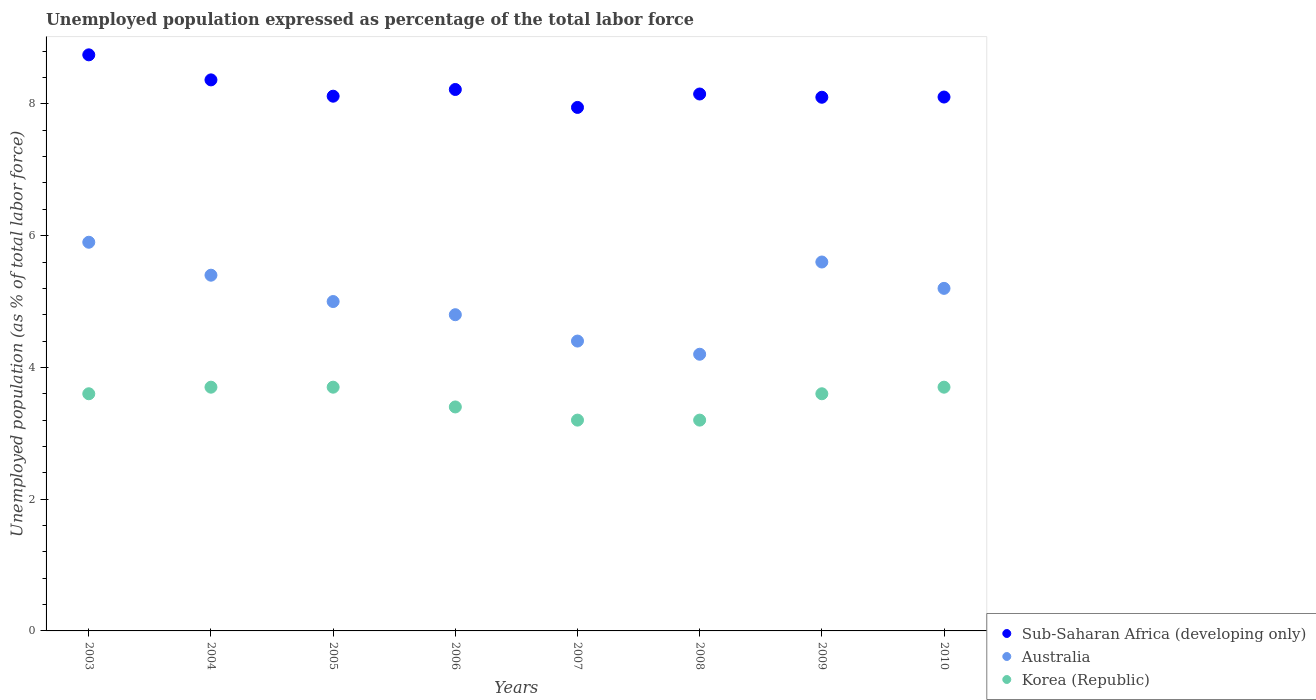How many different coloured dotlines are there?
Offer a very short reply. 3. What is the unemployment in in Korea (Republic) in 2004?
Keep it short and to the point. 3.7. Across all years, what is the maximum unemployment in in Sub-Saharan Africa (developing only)?
Offer a very short reply. 8.74. Across all years, what is the minimum unemployment in in Australia?
Offer a very short reply. 4.2. In which year was the unemployment in in Korea (Republic) maximum?
Provide a short and direct response. 2004. In which year was the unemployment in in Australia minimum?
Keep it short and to the point. 2008. What is the total unemployment in in Australia in the graph?
Offer a terse response. 40.5. What is the difference between the unemployment in in Korea (Republic) in 2006 and that in 2008?
Provide a short and direct response. 0.2. What is the difference between the unemployment in in Sub-Saharan Africa (developing only) in 2004 and the unemployment in in Korea (Republic) in 2009?
Ensure brevity in your answer.  4.76. What is the average unemployment in in Korea (Republic) per year?
Your answer should be compact. 3.51. In the year 2010, what is the difference between the unemployment in in Sub-Saharan Africa (developing only) and unemployment in in Australia?
Provide a short and direct response. 2.9. What is the ratio of the unemployment in in Sub-Saharan Africa (developing only) in 2005 to that in 2006?
Your answer should be very brief. 0.99. Is the unemployment in in Sub-Saharan Africa (developing only) in 2006 less than that in 2008?
Offer a very short reply. No. What is the difference between the highest and the second highest unemployment in in Korea (Republic)?
Your answer should be very brief. 0. What is the difference between the highest and the lowest unemployment in in Australia?
Your answer should be very brief. 1.7. Is the unemployment in in Australia strictly less than the unemployment in in Sub-Saharan Africa (developing only) over the years?
Your answer should be very brief. Yes. How many dotlines are there?
Provide a short and direct response. 3. What is the difference between two consecutive major ticks on the Y-axis?
Offer a terse response. 2. How many legend labels are there?
Keep it short and to the point. 3. What is the title of the graph?
Your response must be concise. Unemployed population expressed as percentage of the total labor force. What is the label or title of the X-axis?
Your answer should be very brief. Years. What is the label or title of the Y-axis?
Make the answer very short. Unemployed population (as % of total labor force). What is the Unemployed population (as % of total labor force) in Sub-Saharan Africa (developing only) in 2003?
Provide a succinct answer. 8.74. What is the Unemployed population (as % of total labor force) of Australia in 2003?
Your response must be concise. 5.9. What is the Unemployed population (as % of total labor force) in Korea (Republic) in 2003?
Give a very brief answer. 3.6. What is the Unemployed population (as % of total labor force) of Sub-Saharan Africa (developing only) in 2004?
Provide a short and direct response. 8.36. What is the Unemployed population (as % of total labor force) in Australia in 2004?
Provide a short and direct response. 5.4. What is the Unemployed population (as % of total labor force) of Korea (Republic) in 2004?
Give a very brief answer. 3.7. What is the Unemployed population (as % of total labor force) in Sub-Saharan Africa (developing only) in 2005?
Provide a short and direct response. 8.12. What is the Unemployed population (as % of total labor force) in Korea (Republic) in 2005?
Provide a succinct answer. 3.7. What is the Unemployed population (as % of total labor force) in Sub-Saharan Africa (developing only) in 2006?
Your response must be concise. 8.22. What is the Unemployed population (as % of total labor force) of Australia in 2006?
Keep it short and to the point. 4.8. What is the Unemployed population (as % of total labor force) in Korea (Republic) in 2006?
Keep it short and to the point. 3.4. What is the Unemployed population (as % of total labor force) of Sub-Saharan Africa (developing only) in 2007?
Offer a terse response. 7.95. What is the Unemployed population (as % of total labor force) in Australia in 2007?
Your answer should be very brief. 4.4. What is the Unemployed population (as % of total labor force) in Korea (Republic) in 2007?
Provide a succinct answer. 3.2. What is the Unemployed population (as % of total labor force) in Sub-Saharan Africa (developing only) in 2008?
Provide a short and direct response. 8.15. What is the Unemployed population (as % of total labor force) in Australia in 2008?
Make the answer very short. 4.2. What is the Unemployed population (as % of total labor force) in Korea (Republic) in 2008?
Give a very brief answer. 3.2. What is the Unemployed population (as % of total labor force) of Sub-Saharan Africa (developing only) in 2009?
Provide a succinct answer. 8.1. What is the Unemployed population (as % of total labor force) in Australia in 2009?
Provide a succinct answer. 5.6. What is the Unemployed population (as % of total labor force) in Korea (Republic) in 2009?
Give a very brief answer. 3.6. What is the Unemployed population (as % of total labor force) of Sub-Saharan Africa (developing only) in 2010?
Make the answer very short. 8.1. What is the Unemployed population (as % of total labor force) of Australia in 2010?
Your answer should be compact. 5.2. What is the Unemployed population (as % of total labor force) of Korea (Republic) in 2010?
Provide a short and direct response. 3.7. Across all years, what is the maximum Unemployed population (as % of total labor force) in Sub-Saharan Africa (developing only)?
Your response must be concise. 8.74. Across all years, what is the maximum Unemployed population (as % of total labor force) of Australia?
Give a very brief answer. 5.9. Across all years, what is the maximum Unemployed population (as % of total labor force) in Korea (Republic)?
Offer a terse response. 3.7. Across all years, what is the minimum Unemployed population (as % of total labor force) in Sub-Saharan Africa (developing only)?
Offer a very short reply. 7.95. Across all years, what is the minimum Unemployed population (as % of total labor force) in Australia?
Ensure brevity in your answer.  4.2. Across all years, what is the minimum Unemployed population (as % of total labor force) of Korea (Republic)?
Keep it short and to the point. 3.2. What is the total Unemployed population (as % of total labor force) in Sub-Saharan Africa (developing only) in the graph?
Offer a terse response. 65.75. What is the total Unemployed population (as % of total labor force) of Australia in the graph?
Provide a short and direct response. 40.5. What is the total Unemployed population (as % of total labor force) in Korea (Republic) in the graph?
Ensure brevity in your answer.  28.1. What is the difference between the Unemployed population (as % of total labor force) in Sub-Saharan Africa (developing only) in 2003 and that in 2004?
Provide a short and direct response. 0.38. What is the difference between the Unemployed population (as % of total labor force) of Australia in 2003 and that in 2004?
Your answer should be compact. 0.5. What is the difference between the Unemployed population (as % of total labor force) in Korea (Republic) in 2003 and that in 2004?
Offer a very short reply. -0.1. What is the difference between the Unemployed population (as % of total labor force) of Sub-Saharan Africa (developing only) in 2003 and that in 2005?
Your answer should be compact. 0.63. What is the difference between the Unemployed population (as % of total labor force) in Korea (Republic) in 2003 and that in 2005?
Give a very brief answer. -0.1. What is the difference between the Unemployed population (as % of total labor force) in Sub-Saharan Africa (developing only) in 2003 and that in 2006?
Offer a terse response. 0.53. What is the difference between the Unemployed population (as % of total labor force) in Sub-Saharan Africa (developing only) in 2003 and that in 2007?
Make the answer very short. 0.8. What is the difference between the Unemployed population (as % of total labor force) of Sub-Saharan Africa (developing only) in 2003 and that in 2008?
Ensure brevity in your answer.  0.59. What is the difference between the Unemployed population (as % of total labor force) in Sub-Saharan Africa (developing only) in 2003 and that in 2009?
Offer a very short reply. 0.64. What is the difference between the Unemployed population (as % of total labor force) in Sub-Saharan Africa (developing only) in 2003 and that in 2010?
Your answer should be compact. 0.64. What is the difference between the Unemployed population (as % of total labor force) of Australia in 2003 and that in 2010?
Offer a terse response. 0.7. What is the difference between the Unemployed population (as % of total labor force) in Korea (Republic) in 2003 and that in 2010?
Keep it short and to the point. -0.1. What is the difference between the Unemployed population (as % of total labor force) of Sub-Saharan Africa (developing only) in 2004 and that in 2005?
Your answer should be very brief. 0.25. What is the difference between the Unemployed population (as % of total labor force) in Korea (Republic) in 2004 and that in 2005?
Provide a short and direct response. 0. What is the difference between the Unemployed population (as % of total labor force) in Sub-Saharan Africa (developing only) in 2004 and that in 2006?
Ensure brevity in your answer.  0.15. What is the difference between the Unemployed population (as % of total labor force) of Korea (Republic) in 2004 and that in 2006?
Keep it short and to the point. 0.3. What is the difference between the Unemployed population (as % of total labor force) of Sub-Saharan Africa (developing only) in 2004 and that in 2007?
Your answer should be compact. 0.42. What is the difference between the Unemployed population (as % of total labor force) of Australia in 2004 and that in 2007?
Your answer should be compact. 1. What is the difference between the Unemployed population (as % of total labor force) in Sub-Saharan Africa (developing only) in 2004 and that in 2008?
Provide a short and direct response. 0.21. What is the difference between the Unemployed population (as % of total labor force) in Sub-Saharan Africa (developing only) in 2004 and that in 2009?
Provide a short and direct response. 0.26. What is the difference between the Unemployed population (as % of total labor force) of Australia in 2004 and that in 2009?
Ensure brevity in your answer.  -0.2. What is the difference between the Unemployed population (as % of total labor force) of Korea (Republic) in 2004 and that in 2009?
Give a very brief answer. 0.1. What is the difference between the Unemployed population (as % of total labor force) in Sub-Saharan Africa (developing only) in 2004 and that in 2010?
Offer a very short reply. 0.26. What is the difference between the Unemployed population (as % of total labor force) in Sub-Saharan Africa (developing only) in 2005 and that in 2006?
Make the answer very short. -0.1. What is the difference between the Unemployed population (as % of total labor force) of Australia in 2005 and that in 2006?
Your answer should be very brief. 0.2. What is the difference between the Unemployed population (as % of total labor force) in Korea (Republic) in 2005 and that in 2006?
Offer a very short reply. 0.3. What is the difference between the Unemployed population (as % of total labor force) of Sub-Saharan Africa (developing only) in 2005 and that in 2007?
Provide a short and direct response. 0.17. What is the difference between the Unemployed population (as % of total labor force) of Australia in 2005 and that in 2007?
Provide a succinct answer. 0.6. What is the difference between the Unemployed population (as % of total labor force) of Sub-Saharan Africa (developing only) in 2005 and that in 2008?
Ensure brevity in your answer.  -0.03. What is the difference between the Unemployed population (as % of total labor force) of Australia in 2005 and that in 2008?
Provide a succinct answer. 0.8. What is the difference between the Unemployed population (as % of total labor force) of Korea (Republic) in 2005 and that in 2008?
Offer a very short reply. 0.5. What is the difference between the Unemployed population (as % of total labor force) of Sub-Saharan Africa (developing only) in 2005 and that in 2009?
Make the answer very short. 0.02. What is the difference between the Unemployed population (as % of total labor force) in Australia in 2005 and that in 2009?
Make the answer very short. -0.6. What is the difference between the Unemployed population (as % of total labor force) in Sub-Saharan Africa (developing only) in 2005 and that in 2010?
Your answer should be compact. 0.01. What is the difference between the Unemployed population (as % of total labor force) in Australia in 2005 and that in 2010?
Keep it short and to the point. -0.2. What is the difference between the Unemployed population (as % of total labor force) of Sub-Saharan Africa (developing only) in 2006 and that in 2007?
Ensure brevity in your answer.  0.27. What is the difference between the Unemployed population (as % of total labor force) of Australia in 2006 and that in 2007?
Give a very brief answer. 0.4. What is the difference between the Unemployed population (as % of total labor force) of Korea (Republic) in 2006 and that in 2007?
Your answer should be very brief. 0.2. What is the difference between the Unemployed population (as % of total labor force) in Sub-Saharan Africa (developing only) in 2006 and that in 2008?
Ensure brevity in your answer.  0.07. What is the difference between the Unemployed population (as % of total labor force) of Australia in 2006 and that in 2008?
Keep it short and to the point. 0.6. What is the difference between the Unemployed population (as % of total labor force) of Korea (Republic) in 2006 and that in 2008?
Ensure brevity in your answer.  0.2. What is the difference between the Unemployed population (as % of total labor force) in Sub-Saharan Africa (developing only) in 2006 and that in 2009?
Give a very brief answer. 0.12. What is the difference between the Unemployed population (as % of total labor force) in Australia in 2006 and that in 2009?
Your answer should be very brief. -0.8. What is the difference between the Unemployed population (as % of total labor force) in Korea (Republic) in 2006 and that in 2009?
Offer a terse response. -0.2. What is the difference between the Unemployed population (as % of total labor force) in Sub-Saharan Africa (developing only) in 2006 and that in 2010?
Your response must be concise. 0.11. What is the difference between the Unemployed population (as % of total labor force) in Sub-Saharan Africa (developing only) in 2007 and that in 2008?
Keep it short and to the point. -0.2. What is the difference between the Unemployed population (as % of total labor force) of Korea (Republic) in 2007 and that in 2008?
Provide a succinct answer. 0. What is the difference between the Unemployed population (as % of total labor force) of Sub-Saharan Africa (developing only) in 2007 and that in 2009?
Offer a terse response. -0.15. What is the difference between the Unemployed population (as % of total labor force) in Australia in 2007 and that in 2009?
Your answer should be compact. -1.2. What is the difference between the Unemployed population (as % of total labor force) in Korea (Republic) in 2007 and that in 2009?
Provide a succinct answer. -0.4. What is the difference between the Unemployed population (as % of total labor force) in Sub-Saharan Africa (developing only) in 2007 and that in 2010?
Your response must be concise. -0.16. What is the difference between the Unemployed population (as % of total labor force) in Australia in 2007 and that in 2010?
Offer a very short reply. -0.8. What is the difference between the Unemployed population (as % of total labor force) of Sub-Saharan Africa (developing only) in 2008 and that in 2009?
Give a very brief answer. 0.05. What is the difference between the Unemployed population (as % of total labor force) in Korea (Republic) in 2008 and that in 2009?
Offer a very short reply. -0.4. What is the difference between the Unemployed population (as % of total labor force) in Sub-Saharan Africa (developing only) in 2008 and that in 2010?
Provide a succinct answer. 0.05. What is the difference between the Unemployed population (as % of total labor force) in Korea (Republic) in 2008 and that in 2010?
Keep it short and to the point. -0.5. What is the difference between the Unemployed population (as % of total labor force) in Sub-Saharan Africa (developing only) in 2009 and that in 2010?
Provide a short and direct response. -0. What is the difference between the Unemployed population (as % of total labor force) in Sub-Saharan Africa (developing only) in 2003 and the Unemployed population (as % of total labor force) in Australia in 2004?
Offer a terse response. 3.34. What is the difference between the Unemployed population (as % of total labor force) of Sub-Saharan Africa (developing only) in 2003 and the Unemployed population (as % of total labor force) of Korea (Republic) in 2004?
Offer a terse response. 5.04. What is the difference between the Unemployed population (as % of total labor force) in Sub-Saharan Africa (developing only) in 2003 and the Unemployed population (as % of total labor force) in Australia in 2005?
Provide a short and direct response. 3.74. What is the difference between the Unemployed population (as % of total labor force) in Sub-Saharan Africa (developing only) in 2003 and the Unemployed population (as % of total labor force) in Korea (Republic) in 2005?
Offer a very short reply. 5.04. What is the difference between the Unemployed population (as % of total labor force) of Australia in 2003 and the Unemployed population (as % of total labor force) of Korea (Republic) in 2005?
Offer a terse response. 2.2. What is the difference between the Unemployed population (as % of total labor force) of Sub-Saharan Africa (developing only) in 2003 and the Unemployed population (as % of total labor force) of Australia in 2006?
Provide a short and direct response. 3.94. What is the difference between the Unemployed population (as % of total labor force) in Sub-Saharan Africa (developing only) in 2003 and the Unemployed population (as % of total labor force) in Korea (Republic) in 2006?
Your response must be concise. 5.34. What is the difference between the Unemployed population (as % of total labor force) of Australia in 2003 and the Unemployed population (as % of total labor force) of Korea (Republic) in 2006?
Give a very brief answer. 2.5. What is the difference between the Unemployed population (as % of total labor force) of Sub-Saharan Africa (developing only) in 2003 and the Unemployed population (as % of total labor force) of Australia in 2007?
Provide a succinct answer. 4.34. What is the difference between the Unemployed population (as % of total labor force) of Sub-Saharan Africa (developing only) in 2003 and the Unemployed population (as % of total labor force) of Korea (Republic) in 2007?
Offer a terse response. 5.54. What is the difference between the Unemployed population (as % of total labor force) of Sub-Saharan Africa (developing only) in 2003 and the Unemployed population (as % of total labor force) of Australia in 2008?
Ensure brevity in your answer.  4.54. What is the difference between the Unemployed population (as % of total labor force) of Sub-Saharan Africa (developing only) in 2003 and the Unemployed population (as % of total labor force) of Korea (Republic) in 2008?
Provide a succinct answer. 5.54. What is the difference between the Unemployed population (as % of total labor force) in Australia in 2003 and the Unemployed population (as % of total labor force) in Korea (Republic) in 2008?
Provide a short and direct response. 2.7. What is the difference between the Unemployed population (as % of total labor force) of Sub-Saharan Africa (developing only) in 2003 and the Unemployed population (as % of total labor force) of Australia in 2009?
Your answer should be compact. 3.14. What is the difference between the Unemployed population (as % of total labor force) of Sub-Saharan Africa (developing only) in 2003 and the Unemployed population (as % of total labor force) of Korea (Republic) in 2009?
Offer a terse response. 5.14. What is the difference between the Unemployed population (as % of total labor force) in Australia in 2003 and the Unemployed population (as % of total labor force) in Korea (Republic) in 2009?
Ensure brevity in your answer.  2.3. What is the difference between the Unemployed population (as % of total labor force) of Sub-Saharan Africa (developing only) in 2003 and the Unemployed population (as % of total labor force) of Australia in 2010?
Your answer should be compact. 3.54. What is the difference between the Unemployed population (as % of total labor force) of Sub-Saharan Africa (developing only) in 2003 and the Unemployed population (as % of total labor force) of Korea (Republic) in 2010?
Give a very brief answer. 5.04. What is the difference between the Unemployed population (as % of total labor force) of Sub-Saharan Africa (developing only) in 2004 and the Unemployed population (as % of total labor force) of Australia in 2005?
Provide a succinct answer. 3.36. What is the difference between the Unemployed population (as % of total labor force) of Sub-Saharan Africa (developing only) in 2004 and the Unemployed population (as % of total labor force) of Korea (Republic) in 2005?
Keep it short and to the point. 4.66. What is the difference between the Unemployed population (as % of total labor force) in Australia in 2004 and the Unemployed population (as % of total labor force) in Korea (Republic) in 2005?
Offer a terse response. 1.7. What is the difference between the Unemployed population (as % of total labor force) in Sub-Saharan Africa (developing only) in 2004 and the Unemployed population (as % of total labor force) in Australia in 2006?
Give a very brief answer. 3.56. What is the difference between the Unemployed population (as % of total labor force) of Sub-Saharan Africa (developing only) in 2004 and the Unemployed population (as % of total labor force) of Korea (Republic) in 2006?
Give a very brief answer. 4.96. What is the difference between the Unemployed population (as % of total labor force) of Sub-Saharan Africa (developing only) in 2004 and the Unemployed population (as % of total labor force) of Australia in 2007?
Ensure brevity in your answer.  3.96. What is the difference between the Unemployed population (as % of total labor force) of Sub-Saharan Africa (developing only) in 2004 and the Unemployed population (as % of total labor force) of Korea (Republic) in 2007?
Your answer should be compact. 5.16. What is the difference between the Unemployed population (as % of total labor force) in Australia in 2004 and the Unemployed population (as % of total labor force) in Korea (Republic) in 2007?
Make the answer very short. 2.2. What is the difference between the Unemployed population (as % of total labor force) of Sub-Saharan Africa (developing only) in 2004 and the Unemployed population (as % of total labor force) of Australia in 2008?
Your answer should be very brief. 4.16. What is the difference between the Unemployed population (as % of total labor force) in Sub-Saharan Africa (developing only) in 2004 and the Unemployed population (as % of total labor force) in Korea (Republic) in 2008?
Your response must be concise. 5.16. What is the difference between the Unemployed population (as % of total labor force) in Australia in 2004 and the Unemployed population (as % of total labor force) in Korea (Republic) in 2008?
Your response must be concise. 2.2. What is the difference between the Unemployed population (as % of total labor force) in Sub-Saharan Africa (developing only) in 2004 and the Unemployed population (as % of total labor force) in Australia in 2009?
Ensure brevity in your answer.  2.76. What is the difference between the Unemployed population (as % of total labor force) of Sub-Saharan Africa (developing only) in 2004 and the Unemployed population (as % of total labor force) of Korea (Republic) in 2009?
Keep it short and to the point. 4.76. What is the difference between the Unemployed population (as % of total labor force) of Australia in 2004 and the Unemployed population (as % of total labor force) of Korea (Republic) in 2009?
Provide a short and direct response. 1.8. What is the difference between the Unemployed population (as % of total labor force) in Sub-Saharan Africa (developing only) in 2004 and the Unemployed population (as % of total labor force) in Australia in 2010?
Provide a short and direct response. 3.16. What is the difference between the Unemployed population (as % of total labor force) in Sub-Saharan Africa (developing only) in 2004 and the Unemployed population (as % of total labor force) in Korea (Republic) in 2010?
Offer a terse response. 4.66. What is the difference between the Unemployed population (as % of total labor force) in Australia in 2004 and the Unemployed population (as % of total labor force) in Korea (Republic) in 2010?
Your answer should be compact. 1.7. What is the difference between the Unemployed population (as % of total labor force) in Sub-Saharan Africa (developing only) in 2005 and the Unemployed population (as % of total labor force) in Australia in 2006?
Offer a terse response. 3.32. What is the difference between the Unemployed population (as % of total labor force) in Sub-Saharan Africa (developing only) in 2005 and the Unemployed population (as % of total labor force) in Korea (Republic) in 2006?
Provide a short and direct response. 4.72. What is the difference between the Unemployed population (as % of total labor force) of Sub-Saharan Africa (developing only) in 2005 and the Unemployed population (as % of total labor force) of Australia in 2007?
Provide a short and direct response. 3.72. What is the difference between the Unemployed population (as % of total labor force) of Sub-Saharan Africa (developing only) in 2005 and the Unemployed population (as % of total labor force) of Korea (Republic) in 2007?
Keep it short and to the point. 4.92. What is the difference between the Unemployed population (as % of total labor force) of Australia in 2005 and the Unemployed population (as % of total labor force) of Korea (Republic) in 2007?
Your response must be concise. 1.8. What is the difference between the Unemployed population (as % of total labor force) in Sub-Saharan Africa (developing only) in 2005 and the Unemployed population (as % of total labor force) in Australia in 2008?
Make the answer very short. 3.92. What is the difference between the Unemployed population (as % of total labor force) in Sub-Saharan Africa (developing only) in 2005 and the Unemployed population (as % of total labor force) in Korea (Republic) in 2008?
Make the answer very short. 4.92. What is the difference between the Unemployed population (as % of total labor force) in Sub-Saharan Africa (developing only) in 2005 and the Unemployed population (as % of total labor force) in Australia in 2009?
Offer a very short reply. 2.52. What is the difference between the Unemployed population (as % of total labor force) in Sub-Saharan Africa (developing only) in 2005 and the Unemployed population (as % of total labor force) in Korea (Republic) in 2009?
Your answer should be very brief. 4.52. What is the difference between the Unemployed population (as % of total labor force) in Sub-Saharan Africa (developing only) in 2005 and the Unemployed population (as % of total labor force) in Australia in 2010?
Offer a terse response. 2.92. What is the difference between the Unemployed population (as % of total labor force) of Sub-Saharan Africa (developing only) in 2005 and the Unemployed population (as % of total labor force) of Korea (Republic) in 2010?
Your response must be concise. 4.42. What is the difference between the Unemployed population (as % of total labor force) of Sub-Saharan Africa (developing only) in 2006 and the Unemployed population (as % of total labor force) of Australia in 2007?
Offer a very short reply. 3.82. What is the difference between the Unemployed population (as % of total labor force) of Sub-Saharan Africa (developing only) in 2006 and the Unemployed population (as % of total labor force) of Korea (Republic) in 2007?
Your answer should be very brief. 5.02. What is the difference between the Unemployed population (as % of total labor force) of Sub-Saharan Africa (developing only) in 2006 and the Unemployed population (as % of total labor force) of Australia in 2008?
Your answer should be very brief. 4.02. What is the difference between the Unemployed population (as % of total labor force) in Sub-Saharan Africa (developing only) in 2006 and the Unemployed population (as % of total labor force) in Korea (Republic) in 2008?
Provide a short and direct response. 5.02. What is the difference between the Unemployed population (as % of total labor force) in Australia in 2006 and the Unemployed population (as % of total labor force) in Korea (Republic) in 2008?
Offer a terse response. 1.6. What is the difference between the Unemployed population (as % of total labor force) in Sub-Saharan Africa (developing only) in 2006 and the Unemployed population (as % of total labor force) in Australia in 2009?
Offer a terse response. 2.62. What is the difference between the Unemployed population (as % of total labor force) in Sub-Saharan Africa (developing only) in 2006 and the Unemployed population (as % of total labor force) in Korea (Republic) in 2009?
Your answer should be very brief. 4.62. What is the difference between the Unemployed population (as % of total labor force) in Australia in 2006 and the Unemployed population (as % of total labor force) in Korea (Republic) in 2009?
Offer a very short reply. 1.2. What is the difference between the Unemployed population (as % of total labor force) in Sub-Saharan Africa (developing only) in 2006 and the Unemployed population (as % of total labor force) in Australia in 2010?
Your answer should be very brief. 3.02. What is the difference between the Unemployed population (as % of total labor force) in Sub-Saharan Africa (developing only) in 2006 and the Unemployed population (as % of total labor force) in Korea (Republic) in 2010?
Offer a terse response. 4.52. What is the difference between the Unemployed population (as % of total labor force) in Australia in 2006 and the Unemployed population (as % of total labor force) in Korea (Republic) in 2010?
Provide a succinct answer. 1.1. What is the difference between the Unemployed population (as % of total labor force) of Sub-Saharan Africa (developing only) in 2007 and the Unemployed population (as % of total labor force) of Australia in 2008?
Provide a succinct answer. 3.75. What is the difference between the Unemployed population (as % of total labor force) in Sub-Saharan Africa (developing only) in 2007 and the Unemployed population (as % of total labor force) in Korea (Republic) in 2008?
Your answer should be compact. 4.75. What is the difference between the Unemployed population (as % of total labor force) in Australia in 2007 and the Unemployed population (as % of total labor force) in Korea (Republic) in 2008?
Offer a terse response. 1.2. What is the difference between the Unemployed population (as % of total labor force) in Sub-Saharan Africa (developing only) in 2007 and the Unemployed population (as % of total labor force) in Australia in 2009?
Offer a terse response. 2.35. What is the difference between the Unemployed population (as % of total labor force) in Sub-Saharan Africa (developing only) in 2007 and the Unemployed population (as % of total labor force) in Korea (Republic) in 2009?
Ensure brevity in your answer.  4.35. What is the difference between the Unemployed population (as % of total labor force) of Sub-Saharan Africa (developing only) in 2007 and the Unemployed population (as % of total labor force) of Australia in 2010?
Keep it short and to the point. 2.75. What is the difference between the Unemployed population (as % of total labor force) in Sub-Saharan Africa (developing only) in 2007 and the Unemployed population (as % of total labor force) in Korea (Republic) in 2010?
Offer a terse response. 4.25. What is the difference between the Unemployed population (as % of total labor force) in Sub-Saharan Africa (developing only) in 2008 and the Unemployed population (as % of total labor force) in Australia in 2009?
Offer a very short reply. 2.55. What is the difference between the Unemployed population (as % of total labor force) of Sub-Saharan Africa (developing only) in 2008 and the Unemployed population (as % of total labor force) of Korea (Republic) in 2009?
Offer a very short reply. 4.55. What is the difference between the Unemployed population (as % of total labor force) in Sub-Saharan Africa (developing only) in 2008 and the Unemployed population (as % of total labor force) in Australia in 2010?
Your answer should be very brief. 2.95. What is the difference between the Unemployed population (as % of total labor force) in Sub-Saharan Africa (developing only) in 2008 and the Unemployed population (as % of total labor force) in Korea (Republic) in 2010?
Your response must be concise. 4.45. What is the difference between the Unemployed population (as % of total labor force) of Australia in 2008 and the Unemployed population (as % of total labor force) of Korea (Republic) in 2010?
Your answer should be compact. 0.5. What is the difference between the Unemployed population (as % of total labor force) of Sub-Saharan Africa (developing only) in 2009 and the Unemployed population (as % of total labor force) of Australia in 2010?
Ensure brevity in your answer.  2.9. What is the difference between the Unemployed population (as % of total labor force) of Sub-Saharan Africa (developing only) in 2009 and the Unemployed population (as % of total labor force) of Korea (Republic) in 2010?
Ensure brevity in your answer.  4.4. What is the difference between the Unemployed population (as % of total labor force) of Australia in 2009 and the Unemployed population (as % of total labor force) of Korea (Republic) in 2010?
Your answer should be compact. 1.9. What is the average Unemployed population (as % of total labor force) of Sub-Saharan Africa (developing only) per year?
Offer a very short reply. 8.22. What is the average Unemployed population (as % of total labor force) in Australia per year?
Provide a succinct answer. 5.06. What is the average Unemployed population (as % of total labor force) in Korea (Republic) per year?
Ensure brevity in your answer.  3.51. In the year 2003, what is the difference between the Unemployed population (as % of total labor force) in Sub-Saharan Africa (developing only) and Unemployed population (as % of total labor force) in Australia?
Offer a very short reply. 2.84. In the year 2003, what is the difference between the Unemployed population (as % of total labor force) of Sub-Saharan Africa (developing only) and Unemployed population (as % of total labor force) of Korea (Republic)?
Your answer should be very brief. 5.14. In the year 2004, what is the difference between the Unemployed population (as % of total labor force) of Sub-Saharan Africa (developing only) and Unemployed population (as % of total labor force) of Australia?
Offer a very short reply. 2.96. In the year 2004, what is the difference between the Unemployed population (as % of total labor force) in Sub-Saharan Africa (developing only) and Unemployed population (as % of total labor force) in Korea (Republic)?
Provide a short and direct response. 4.66. In the year 2004, what is the difference between the Unemployed population (as % of total labor force) in Australia and Unemployed population (as % of total labor force) in Korea (Republic)?
Offer a terse response. 1.7. In the year 2005, what is the difference between the Unemployed population (as % of total labor force) in Sub-Saharan Africa (developing only) and Unemployed population (as % of total labor force) in Australia?
Give a very brief answer. 3.12. In the year 2005, what is the difference between the Unemployed population (as % of total labor force) in Sub-Saharan Africa (developing only) and Unemployed population (as % of total labor force) in Korea (Republic)?
Offer a terse response. 4.42. In the year 2006, what is the difference between the Unemployed population (as % of total labor force) of Sub-Saharan Africa (developing only) and Unemployed population (as % of total labor force) of Australia?
Offer a very short reply. 3.42. In the year 2006, what is the difference between the Unemployed population (as % of total labor force) in Sub-Saharan Africa (developing only) and Unemployed population (as % of total labor force) in Korea (Republic)?
Your answer should be very brief. 4.82. In the year 2007, what is the difference between the Unemployed population (as % of total labor force) in Sub-Saharan Africa (developing only) and Unemployed population (as % of total labor force) in Australia?
Offer a terse response. 3.55. In the year 2007, what is the difference between the Unemployed population (as % of total labor force) of Sub-Saharan Africa (developing only) and Unemployed population (as % of total labor force) of Korea (Republic)?
Provide a succinct answer. 4.75. In the year 2008, what is the difference between the Unemployed population (as % of total labor force) of Sub-Saharan Africa (developing only) and Unemployed population (as % of total labor force) of Australia?
Provide a short and direct response. 3.95. In the year 2008, what is the difference between the Unemployed population (as % of total labor force) of Sub-Saharan Africa (developing only) and Unemployed population (as % of total labor force) of Korea (Republic)?
Ensure brevity in your answer.  4.95. In the year 2009, what is the difference between the Unemployed population (as % of total labor force) in Sub-Saharan Africa (developing only) and Unemployed population (as % of total labor force) in Australia?
Your answer should be compact. 2.5. In the year 2009, what is the difference between the Unemployed population (as % of total labor force) of Sub-Saharan Africa (developing only) and Unemployed population (as % of total labor force) of Korea (Republic)?
Give a very brief answer. 4.5. In the year 2009, what is the difference between the Unemployed population (as % of total labor force) in Australia and Unemployed population (as % of total labor force) in Korea (Republic)?
Ensure brevity in your answer.  2. In the year 2010, what is the difference between the Unemployed population (as % of total labor force) in Sub-Saharan Africa (developing only) and Unemployed population (as % of total labor force) in Australia?
Provide a succinct answer. 2.9. In the year 2010, what is the difference between the Unemployed population (as % of total labor force) of Sub-Saharan Africa (developing only) and Unemployed population (as % of total labor force) of Korea (Republic)?
Provide a succinct answer. 4.4. In the year 2010, what is the difference between the Unemployed population (as % of total labor force) of Australia and Unemployed population (as % of total labor force) of Korea (Republic)?
Your answer should be very brief. 1.5. What is the ratio of the Unemployed population (as % of total labor force) of Sub-Saharan Africa (developing only) in 2003 to that in 2004?
Ensure brevity in your answer.  1.05. What is the ratio of the Unemployed population (as % of total labor force) in Australia in 2003 to that in 2004?
Provide a short and direct response. 1.09. What is the ratio of the Unemployed population (as % of total labor force) in Sub-Saharan Africa (developing only) in 2003 to that in 2005?
Provide a short and direct response. 1.08. What is the ratio of the Unemployed population (as % of total labor force) of Australia in 2003 to that in 2005?
Offer a terse response. 1.18. What is the ratio of the Unemployed population (as % of total labor force) of Sub-Saharan Africa (developing only) in 2003 to that in 2006?
Keep it short and to the point. 1.06. What is the ratio of the Unemployed population (as % of total labor force) of Australia in 2003 to that in 2006?
Give a very brief answer. 1.23. What is the ratio of the Unemployed population (as % of total labor force) of Korea (Republic) in 2003 to that in 2006?
Your answer should be compact. 1.06. What is the ratio of the Unemployed population (as % of total labor force) of Sub-Saharan Africa (developing only) in 2003 to that in 2007?
Provide a succinct answer. 1.1. What is the ratio of the Unemployed population (as % of total labor force) of Australia in 2003 to that in 2007?
Your response must be concise. 1.34. What is the ratio of the Unemployed population (as % of total labor force) in Sub-Saharan Africa (developing only) in 2003 to that in 2008?
Keep it short and to the point. 1.07. What is the ratio of the Unemployed population (as % of total labor force) of Australia in 2003 to that in 2008?
Provide a succinct answer. 1.4. What is the ratio of the Unemployed population (as % of total labor force) of Korea (Republic) in 2003 to that in 2008?
Ensure brevity in your answer.  1.12. What is the ratio of the Unemployed population (as % of total labor force) in Sub-Saharan Africa (developing only) in 2003 to that in 2009?
Ensure brevity in your answer.  1.08. What is the ratio of the Unemployed population (as % of total labor force) of Australia in 2003 to that in 2009?
Keep it short and to the point. 1.05. What is the ratio of the Unemployed population (as % of total labor force) in Korea (Republic) in 2003 to that in 2009?
Ensure brevity in your answer.  1. What is the ratio of the Unemployed population (as % of total labor force) of Sub-Saharan Africa (developing only) in 2003 to that in 2010?
Your response must be concise. 1.08. What is the ratio of the Unemployed population (as % of total labor force) of Australia in 2003 to that in 2010?
Make the answer very short. 1.13. What is the ratio of the Unemployed population (as % of total labor force) in Korea (Republic) in 2003 to that in 2010?
Ensure brevity in your answer.  0.97. What is the ratio of the Unemployed population (as % of total labor force) in Sub-Saharan Africa (developing only) in 2004 to that in 2005?
Provide a short and direct response. 1.03. What is the ratio of the Unemployed population (as % of total labor force) in Korea (Republic) in 2004 to that in 2005?
Make the answer very short. 1. What is the ratio of the Unemployed population (as % of total labor force) in Sub-Saharan Africa (developing only) in 2004 to that in 2006?
Offer a terse response. 1.02. What is the ratio of the Unemployed population (as % of total labor force) in Korea (Republic) in 2004 to that in 2006?
Ensure brevity in your answer.  1.09. What is the ratio of the Unemployed population (as % of total labor force) in Sub-Saharan Africa (developing only) in 2004 to that in 2007?
Give a very brief answer. 1.05. What is the ratio of the Unemployed population (as % of total labor force) in Australia in 2004 to that in 2007?
Your response must be concise. 1.23. What is the ratio of the Unemployed population (as % of total labor force) of Korea (Republic) in 2004 to that in 2007?
Your answer should be very brief. 1.16. What is the ratio of the Unemployed population (as % of total labor force) of Sub-Saharan Africa (developing only) in 2004 to that in 2008?
Offer a very short reply. 1.03. What is the ratio of the Unemployed population (as % of total labor force) of Korea (Republic) in 2004 to that in 2008?
Provide a short and direct response. 1.16. What is the ratio of the Unemployed population (as % of total labor force) of Sub-Saharan Africa (developing only) in 2004 to that in 2009?
Offer a terse response. 1.03. What is the ratio of the Unemployed population (as % of total labor force) of Korea (Republic) in 2004 to that in 2009?
Provide a short and direct response. 1.03. What is the ratio of the Unemployed population (as % of total labor force) in Sub-Saharan Africa (developing only) in 2004 to that in 2010?
Provide a succinct answer. 1.03. What is the ratio of the Unemployed population (as % of total labor force) in Sub-Saharan Africa (developing only) in 2005 to that in 2006?
Ensure brevity in your answer.  0.99. What is the ratio of the Unemployed population (as % of total labor force) in Australia in 2005 to that in 2006?
Offer a terse response. 1.04. What is the ratio of the Unemployed population (as % of total labor force) of Korea (Republic) in 2005 to that in 2006?
Your answer should be compact. 1.09. What is the ratio of the Unemployed population (as % of total labor force) of Sub-Saharan Africa (developing only) in 2005 to that in 2007?
Provide a succinct answer. 1.02. What is the ratio of the Unemployed population (as % of total labor force) in Australia in 2005 to that in 2007?
Your response must be concise. 1.14. What is the ratio of the Unemployed population (as % of total labor force) of Korea (Republic) in 2005 to that in 2007?
Provide a short and direct response. 1.16. What is the ratio of the Unemployed population (as % of total labor force) of Sub-Saharan Africa (developing only) in 2005 to that in 2008?
Ensure brevity in your answer.  1. What is the ratio of the Unemployed population (as % of total labor force) of Australia in 2005 to that in 2008?
Make the answer very short. 1.19. What is the ratio of the Unemployed population (as % of total labor force) in Korea (Republic) in 2005 to that in 2008?
Offer a very short reply. 1.16. What is the ratio of the Unemployed population (as % of total labor force) in Sub-Saharan Africa (developing only) in 2005 to that in 2009?
Keep it short and to the point. 1. What is the ratio of the Unemployed population (as % of total labor force) of Australia in 2005 to that in 2009?
Your answer should be compact. 0.89. What is the ratio of the Unemployed population (as % of total labor force) in Korea (Republic) in 2005 to that in 2009?
Keep it short and to the point. 1.03. What is the ratio of the Unemployed population (as % of total labor force) in Sub-Saharan Africa (developing only) in 2005 to that in 2010?
Offer a very short reply. 1. What is the ratio of the Unemployed population (as % of total labor force) of Australia in 2005 to that in 2010?
Offer a very short reply. 0.96. What is the ratio of the Unemployed population (as % of total labor force) of Sub-Saharan Africa (developing only) in 2006 to that in 2007?
Offer a very short reply. 1.03. What is the ratio of the Unemployed population (as % of total labor force) in Australia in 2006 to that in 2007?
Provide a short and direct response. 1.09. What is the ratio of the Unemployed population (as % of total labor force) of Sub-Saharan Africa (developing only) in 2006 to that in 2008?
Offer a very short reply. 1.01. What is the ratio of the Unemployed population (as % of total labor force) of Australia in 2006 to that in 2008?
Ensure brevity in your answer.  1.14. What is the ratio of the Unemployed population (as % of total labor force) of Sub-Saharan Africa (developing only) in 2006 to that in 2009?
Offer a terse response. 1.01. What is the ratio of the Unemployed population (as % of total labor force) of Sub-Saharan Africa (developing only) in 2006 to that in 2010?
Give a very brief answer. 1.01. What is the ratio of the Unemployed population (as % of total labor force) of Australia in 2006 to that in 2010?
Provide a short and direct response. 0.92. What is the ratio of the Unemployed population (as % of total labor force) in Korea (Republic) in 2006 to that in 2010?
Your response must be concise. 0.92. What is the ratio of the Unemployed population (as % of total labor force) of Sub-Saharan Africa (developing only) in 2007 to that in 2008?
Your answer should be compact. 0.97. What is the ratio of the Unemployed population (as % of total labor force) in Australia in 2007 to that in 2008?
Offer a terse response. 1.05. What is the ratio of the Unemployed population (as % of total labor force) in Sub-Saharan Africa (developing only) in 2007 to that in 2009?
Make the answer very short. 0.98. What is the ratio of the Unemployed population (as % of total labor force) of Australia in 2007 to that in 2009?
Provide a succinct answer. 0.79. What is the ratio of the Unemployed population (as % of total labor force) of Korea (Republic) in 2007 to that in 2009?
Make the answer very short. 0.89. What is the ratio of the Unemployed population (as % of total labor force) in Sub-Saharan Africa (developing only) in 2007 to that in 2010?
Keep it short and to the point. 0.98. What is the ratio of the Unemployed population (as % of total labor force) in Australia in 2007 to that in 2010?
Provide a short and direct response. 0.85. What is the ratio of the Unemployed population (as % of total labor force) of Korea (Republic) in 2007 to that in 2010?
Offer a terse response. 0.86. What is the ratio of the Unemployed population (as % of total labor force) in Korea (Republic) in 2008 to that in 2009?
Offer a terse response. 0.89. What is the ratio of the Unemployed population (as % of total labor force) of Sub-Saharan Africa (developing only) in 2008 to that in 2010?
Provide a succinct answer. 1.01. What is the ratio of the Unemployed population (as % of total labor force) of Australia in 2008 to that in 2010?
Your answer should be very brief. 0.81. What is the ratio of the Unemployed population (as % of total labor force) in Korea (Republic) in 2008 to that in 2010?
Offer a very short reply. 0.86. What is the ratio of the Unemployed population (as % of total labor force) of Sub-Saharan Africa (developing only) in 2009 to that in 2010?
Provide a short and direct response. 1. What is the ratio of the Unemployed population (as % of total labor force) in Australia in 2009 to that in 2010?
Your response must be concise. 1.08. What is the ratio of the Unemployed population (as % of total labor force) of Korea (Republic) in 2009 to that in 2010?
Offer a terse response. 0.97. What is the difference between the highest and the second highest Unemployed population (as % of total labor force) of Sub-Saharan Africa (developing only)?
Keep it short and to the point. 0.38. What is the difference between the highest and the second highest Unemployed population (as % of total labor force) in Australia?
Give a very brief answer. 0.3. What is the difference between the highest and the second highest Unemployed population (as % of total labor force) of Korea (Republic)?
Provide a short and direct response. 0. What is the difference between the highest and the lowest Unemployed population (as % of total labor force) in Sub-Saharan Africa (developing only)?
Make the answer very short. 0.8. What is the difference between the highest and the lowest Unemployed population (as % of total labor force) of Korea (Republic)?
Give a very brief answer. 0.5. 